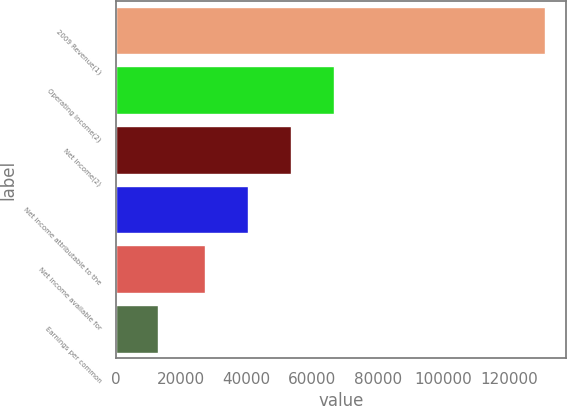Convert chart. <chart><loc_0><loc_0><loc_500><loc_500><bar_chart><fcel>2009 Revenue(1)<fcel>Operating Income(2)<fcel>Net income(2)<fcel>Net income attributable to the<fcel>Net income available for<fcel>Earnings per common<nl><fcel>130841<fcel>66549.2<fcel>53465.1<fcel>40381.1<fcel>27297<fcel>13084.5<nl></chart> 